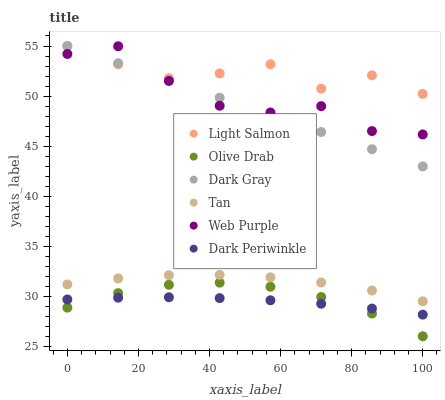Does Dark Periwinkle have the minimum area under the curve?
Answer yes or no. Yes. Does Light Salmon have the maximum area under the curve?
Answer yes or no. Yes. Does Dark Gray have the minimum area under the curve?
Answer yes or no. No. Does Dark Gray have the maximum area under the curve?
Answer yes or no. No. Is Dark Gray the smoothest?
Answer yes or no. Yes. Is Web Purple the roughest?
Answer yes or no. Yes. Is Web Purple the smoothest?
Answer yes or no. No. Is Dark Gray the roughest?
Answer yes or no. No. Does Olive Drab have the lowest value?
Answer yes or no. Yes. Does Dark Gray have the lowest value?
Answer yes or no. No. Does Dark Gray have the highest value?
Answer yes or no. Yes. Does Web Purple have the highest value?
Answer yes or no. No. Is Dark Periwinkle less than Light Salmon?
Answer yes or no. Yes. Is Dark Gray greater than Tan?
Answer yes or no. Yes. Does Olive Drab intersect Dark Periwinkle?
Answer yes or no. Yes. Is Olive Drab less than Dark Periwinkle?
Answer yes or no. No. Is Olive Drab greater than Dark Periwinkle?
Answer yes or no. No. Does Dark Periwinkle intersect Light Salmon?
Answer yes or no. No. 